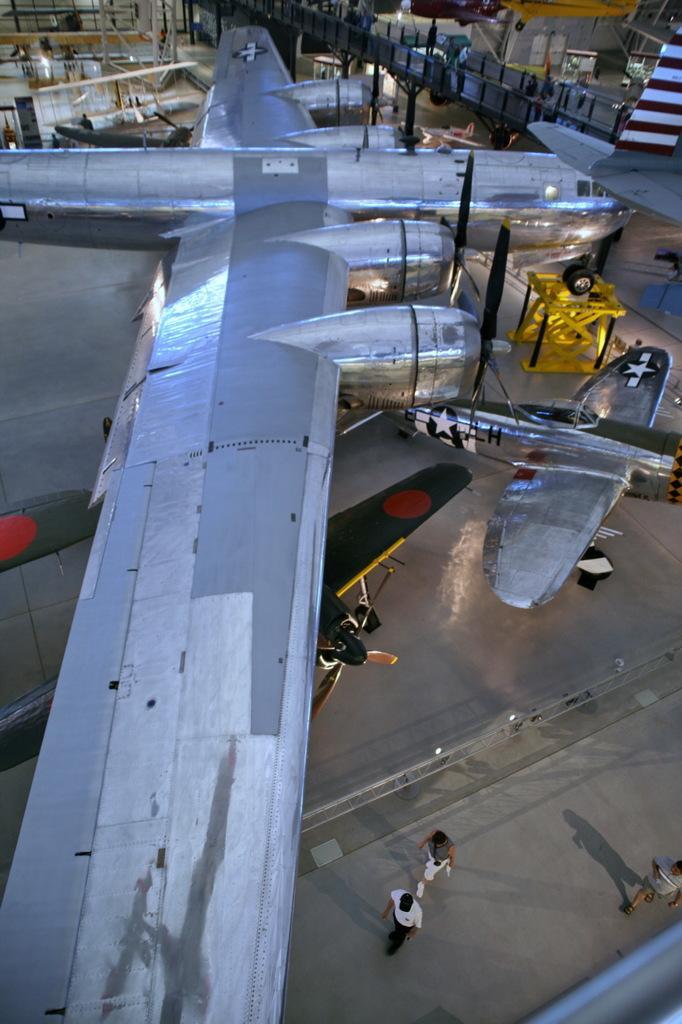Please provide a concise description of this image. in this picture I can see a aeroplane and couple of small planes and few people walking and we see a lifting up crane and picture looks like a aeroplane manufacturing unit. 